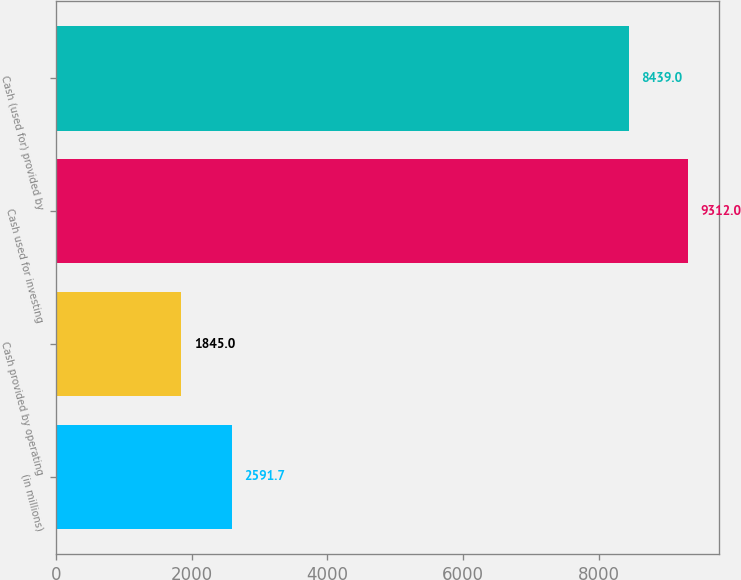<chart> <loc_0><loc_0><loc_500><loc_500><bar_chart><fcel>(in millions)<fcel>Cash provided by operating<fcel>Cash used for investing<fcel>Cash (used for) provided by<nl><fcel>2591.7<fcel>1845<fcel>9312<fcel>8439<nl></chart> 